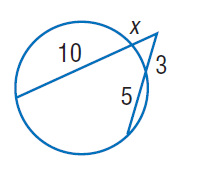Question: Find x. Round to the nearest tenth if necessary.
Choices:
A. 2
B. 3
C. 5
D. 10
Answer with the letter. Answer: A 